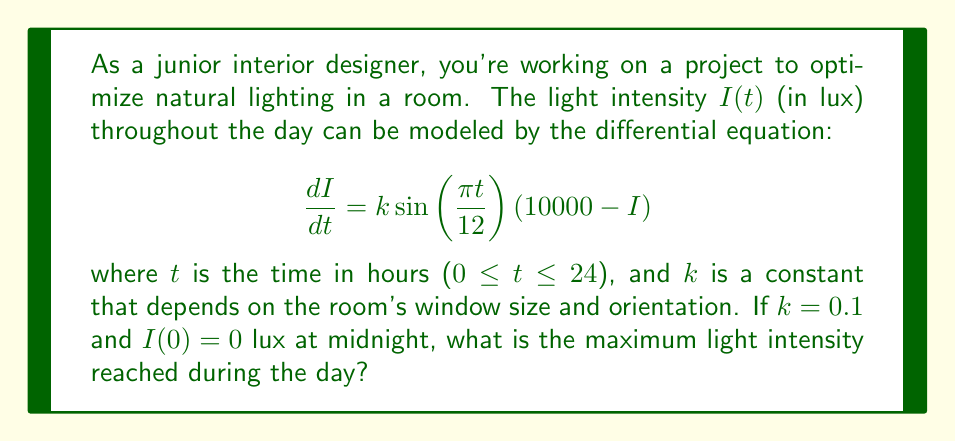Provide a solution to this math problem. To solve this problem, we need to follow these steps:

1) First, we recognize that this is a separable differential equation. We can rewrite it as:

   $$\frac{dI}{10000 - I} = k \sin\left(\frac{\pi t}{12}\right) dt$$

2) Integrating both sides:

   $$-\ln|10000 - I| = -\frac{12k}{\pi} \cos\left(\frac{\pi t}{12}\right) + C$$

3) Solving for $I$:

   $$I = 10000 - Ae^{\frac{12k}{\pi} \cos\left(\frac{\pi t}{12}\right)}$$

   where $A$ is a constant of integration.

4) Using the initial condition $I(0) = 0$, we can find $A$:

   $$0 = 10000 - Ae^{\frac{12k}{\pi}}$$
   $$A = 10000e^{-\frac{12k}{\pi}}$$

5) Therefore, the general solution is:

   $$I(t) = 10000 \left(1 - e^{\frac{12k}{\pi}\left(\cos\left(\frac{\pi t}{12}\right) - 1\right)}\right)$$

6) To find the maximum intensity, we need to find when $\frac{dI}{dt} = 0$. This occurs when $\sin\left(\frac{\pi t}{12}\right) = 0$, which happens at $t = 12$ (noon).

7) Substituting $t = 12$ and $k = 0.1$ into our solution:

   $$I_{max} = I(12) = 10000 \left(1 - e^{\frac{12(0.1)}{\pi}\left(\cos\left(\frac{\pi 12}{12}\right) - 1\right)}\right)$$
   $$= 10000 \left(1 - e^{\frac{1.2}{\pi}\left(-2\right)}\right)$$
   $$≈ 7052.14$$ lux

Therefore, the maximum light intensity reached during the day is approximately 7052.14 lux.
Answer: The maximum light intensity reached during the day is approximately 7052.14 lux. 